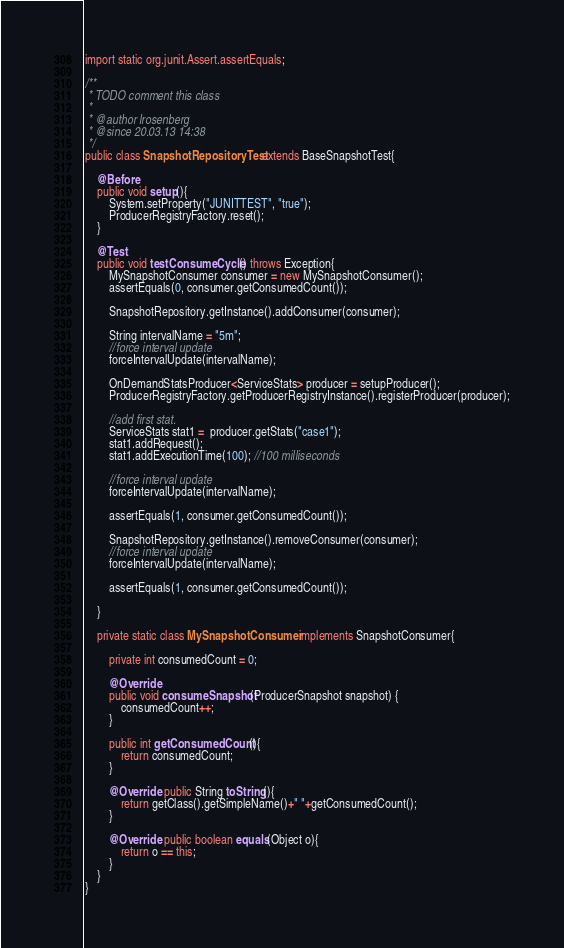<code> <loc_0><loc_0><loc_500><loc_500><_Java_>import static org.junit.Assert.assertEquals;

/**
 * TODO comment this class
 *
 * @author lrosenberg
 * @since 20.03.13 14:38
 */
public class SnapshotRepositoryTest extends BaseSnapshotTest{

	@Before
	public void setup(){
		System.setProperty("JUNITTEST", "true");
		ProducerRegistryFactory.reset();
	}

	@Test
	public void testConsumeCycle() throws Exception{
		MySnapshotConsumer consumer = new MySnapshotConsumer();
		assertEquals(0, consumer.getConsumedCount());

		SnapshotRepository.getInstance().addConsumer(consumer);

		String intervalName = "5m";
		//force interval update
		forceIntervalUpdate(intervalName);

		OnDemandStatsProducer<ServiceStats> producer = setupProducer();
		ProducerRegistryFactory.getProducerRegistryInstance().registerProducer(producer);

		//add first stat.
		ServiceStats stat1 =  producer.getStats("case1");
		stat1.addRequest();
		stat1.addExecutionTime(100); //100 milliseconds

		//force interval update
		forceIntervalUpdate(intervalName);

		assertEquals(1, consumer.getConsumedCount());

		SnapshotRepository.getInstance().removeConsumer(consumer);
		//force interval update
		forceIntervalUpdate(intervalName);

		assertEquals(1, consumer.getConsumedCount());

	}

	private static class MySnapshotConsumer implements SnapshotConsumer{

		private int consumedCount = 0;

		@Override
		public void consumeSnapshot(ProducerSnapshot snapshot) {
			consumedCount++;
		}

		public int getConsumedCount(){
			return consumedCount;
		}

		@Override public String toString(){
			return getClass().getSimpleName()+" "+getConsumedCount();
		}

		@Override public boolean equals(Object o){
			return o == this;
		}
	}
}

</code> 